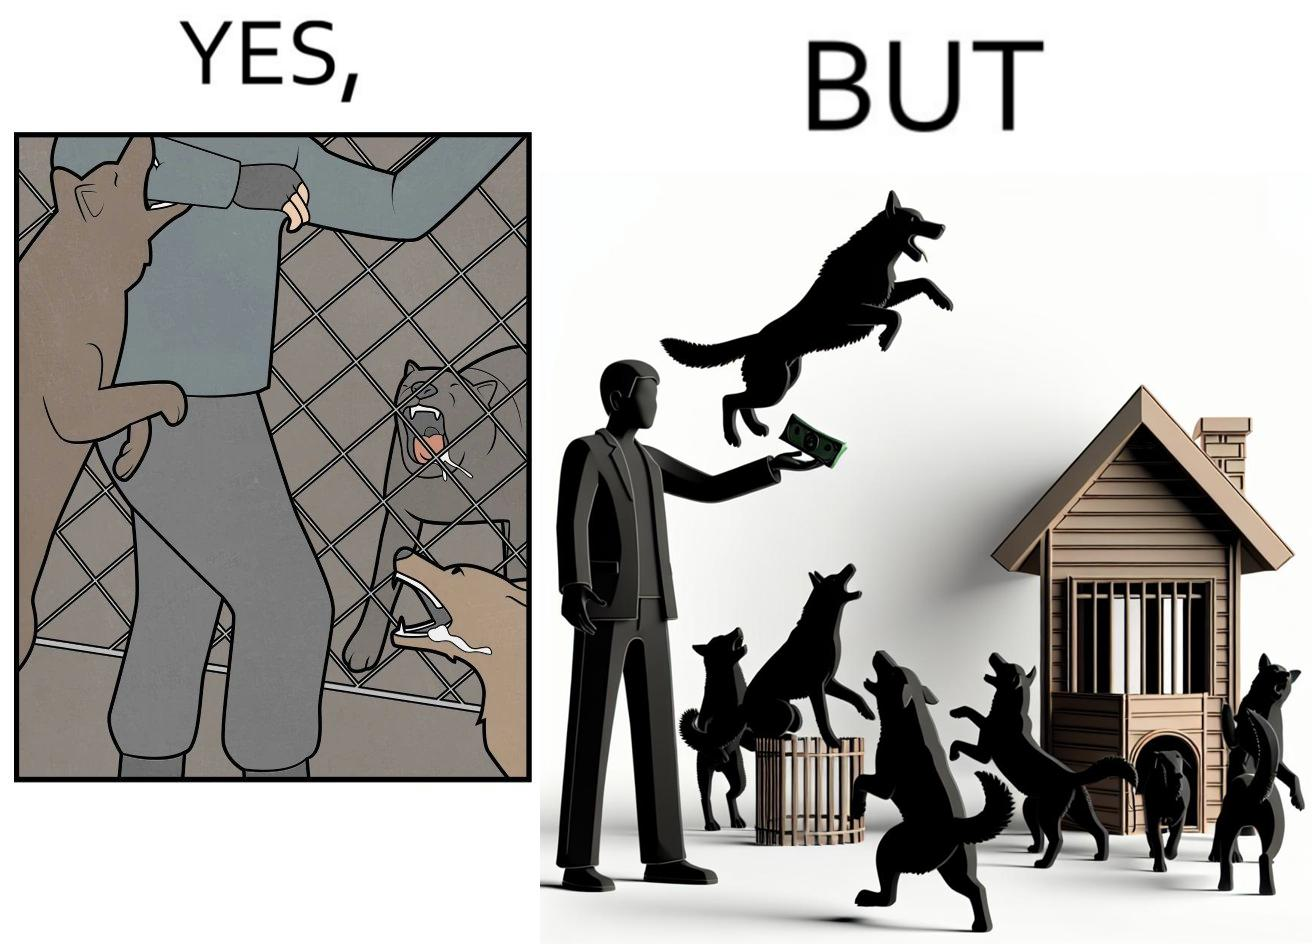Is this a satirical image? Yes, this image is satirical. 